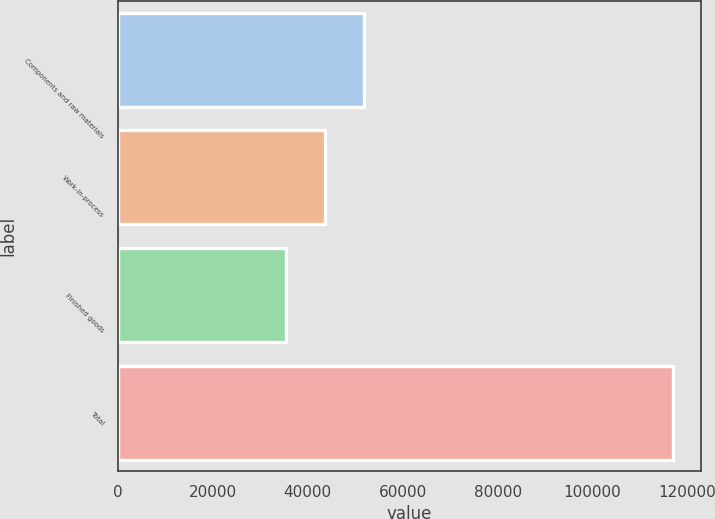Convert chart to OTSL. <chart><loc_0><loc_0><loc_500><loc_500><bar_chart><fcel>Components and raw materials<fcel>Work-in-process<fcel>Finished goods<fcel>Total<nl><fcel>51788.4<fcel>43639.7<fcel>35491<fcel>116978<nl></chart> 